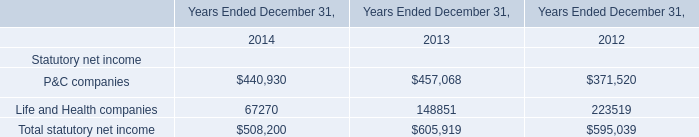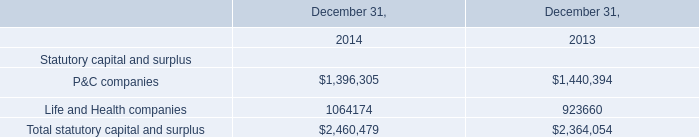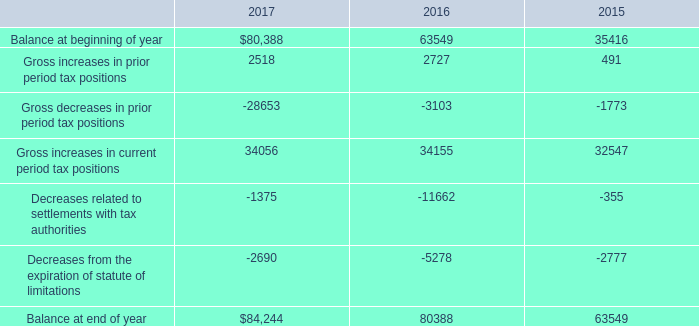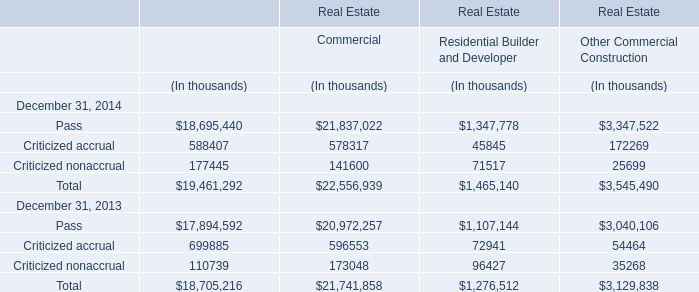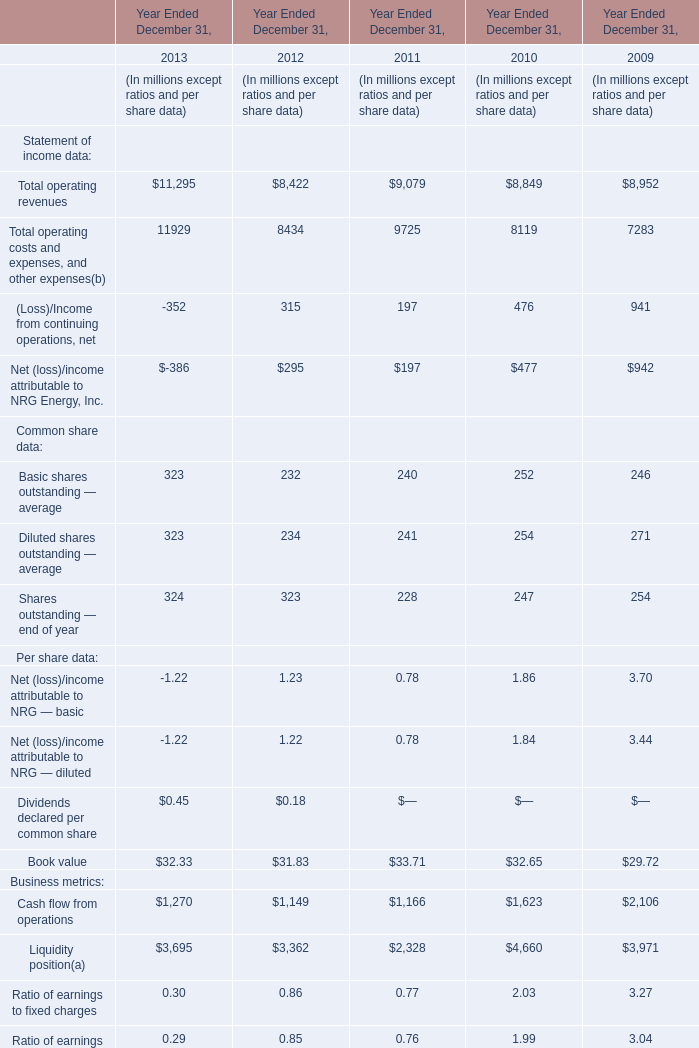What is the sum of Per share data in the range of 0 and 200 in 2011? (in million) 
Computations: ((0.78 + 0.78) + 33.71)
Answer: 35.27. 